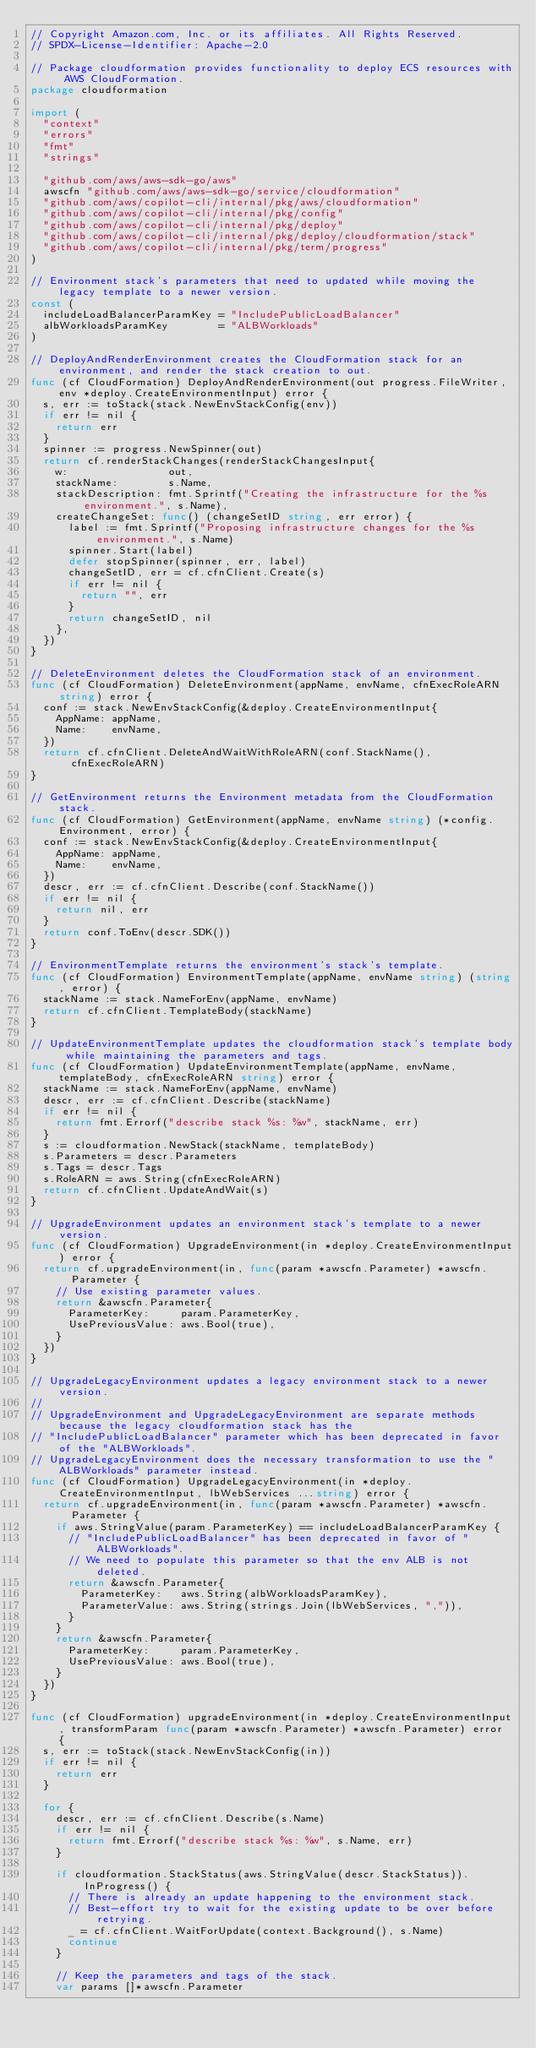<code> <loc_0><loc_0><loc_500><loc_500><_Go_>// Copyright Amazon.com, Inc. or its affiliates. All Rights Reserved.
// SPDX-License-Identifier: Apache-2.0

// Package cloudformation provides functionality to deploy ECS resources with AWS CloudFormation.
package cloudformation

import (
	"context"
	"errors"
	"fmt"
	"strings"

	"github.com/aws/aws-sdk-go/aws"
	awscfn "github.com/aws/aws-sdk-go/service/cloudformation"
	"github.com/aws/copilot-cli/internal/pkg/aws/cloudformation"
	"github.com/aws/copilot-cli/internal/pkg/config"
	"github.com/aws/copilot-cli/internal/pkg/deploy"
	"github.com/aws/copilot-cli/internal/pkg/deploy/cloudformation/stack"
	"github.com/aws/copilot-cli/internal/pkg/term/progress"
)

// Environment stack's parameters that need to updated while moving the legacy template to a newer version.
const (
	includeLoadBalancerParamKey = "IncludePublicLoadBalancer"
	albWorkloadsParamKey        = "ALBWorkloads"
)

// DeployAndRenderEnvironment creates the CloudFormation stack for an environment, and render the stack creation to out.
func (cf CloudFormation) DeployAndRenderEnvironment(out progress.FileWriter, env *deploy.CreateEnvironmentInput) error {
	s, err := toStack(stack.NewEnvStackConfig(env))
	if err != nil {
		return err
	}
	spinner := progress.NewSpinner(out)
	return cf.renderStackChanges(renderStackChangesInput{
		w:                out,
		stackName:        s.Name,
		stackDescription: fmt.Sprintf("Creating the infrastructure for the %s environment.", s.Name),
		createChangeSet: func() (changeSetID string, err error) {
			label := fmt.Sprintf("Proposing infrastructure changes for the %s environment.", s.Name)
			spinner.Start(label)
			defer stopSpinner(spinner, err, label)
			changeSetID, err = cf.cfnClient.Create(s)
			if err != nil {
				return "", err
			}
			return changeSetID, nil
		},
	})
}

// DeleteEnvironment deletes the CloudFormation stack of an environment.
func (cf CloudFormation) DeleteEnvironment(appName, envName, cfnExecRoleARN string) error {
	conf := stack.NewEnvStackConfig(&deploy.CreateEnvironmentInput{
		AppName: appName,
		Name:    envName,
	})
	return cf.cfnClient.DeleteAndWaitWithRoleARN(conf.StackName(), cfnExecRoleARN)
}

// GetEnvironment returns the Environment metadata from the CloudFormation stack.
func (cf CloudFormation) GetEnvironment(appName, envName string) (*config.Environment, error) {
	conf := stack.NewEnvStackConfig(&deploy.CreateEnvironmentInput{
		AppName: appName,
		Name:    envName,
	})
	descr, err := cf.cfnClient.Describe(conf.StackName())
	if err != nil {
		return nil, err
	}
	return conf.ToEnv(descr.SDK())
}

// EnvironmentTemplate returns the environment's stack's template.
func (cf CloudFormation) EnvironmentTemplate(appName, envName string) (string, error) {
	stackName := stack.NameForEnv(appName, envName)
	return cf.cfnClient.TemplateBody(stackName)
}

// UpdateEnvironmentTemplate updates the cloudformation stack's template body while maintaining the parameters and tags.
func (cf CloudFormation) UpdateEnvironmentTemplate(appName, envName, templateBody, cfnExecRoleARN string) error {
	stackName := stack.NameForEnv(appName, envName)
	descr, err := cf.cfnClient.Describe(stackName)
	if err != nil {
		return fmt.Errorf("describe stack %s: %w", stackName, err)
	}
	s := cloudformation.NewStack(stackName, templateBody)
	s.Parameters = descr.Parameters
	s.Tags = descr.Tags
	s.RoleARN = aws.String(cfnExecRoleARN)
	return cf.cfnClient.UpdateAndWait(s)
}

// UpgradeEnvironment updates an environment stack's template to a newer version.
func (cf CloudFormation) UpgradeEnvironment(in *deploy.CreateEnvironmentInput) error {
	return cf.upgradeEnvironment(in, func(param *awscfn.Parameter) *awscfn.Parameter {
		// Use existing parameter values.
		return &awscfn.Parameter{
			ParameterKey:     param.ParameterKey,
			UsePreviousValue: aws.Bool(true),
		}
	})
}

// UpgradeLegacyEnvironment updates a legacy environment stack to a newer version.
//
// UpgradeEnvironment and UpgradeLegacyEnvironment are separate methods because the legacy cloudformation stack has the
// "IncludePublicLoadBalancer" parameter which has been deprecated in favor of the "ALBWorkloads".
// UpgradeLegacyEnvironment does the necessary transformation to use the "ALBWorkloads" parameter instead.
func (cf CloudFormation) UpgradeLegacyEnvironment(in *deploy.CreateEnvironmentInput, lbWebServices ...string) error {
	return cf.upgradeEnvironment(in, func(param *awscfn.Parameter) *awscfn.Parameter {
		if aws.StringValue(param.ParameterKey) == includeLoadBalancerParamKey {
			// "IncludePublicLoadBalancer" has been deprecated in favor of "ALBWorkloads".
			// We need to populate this parameter so that the env ALB is not deleted.
			return &awscfn.Parameter{
				ParameterKey:   aws.String(albWorkloadsParamKey),
				ParameterValue: aws.String(strings.Join(lbWebServices, ",")),
			}
		}
		return &awscfn.Parameter{
			ParameterKey:     param.ParameterKey,
			UsePreviousValue: aws.Bool(true),
		}
	})
}

func (cf CloudFormation) upgradeEnvironment(in *deploy.CreateEnvironmentInput, transformParam func(param *awscfn.Parameter) *awscfn.Parameter) error {
	s, err := toStack(stack.NewEnvStackConfig(in))
	if err != nil {
		return err
	}

	for {
		descr, err := cf.cfnClient.Describe(s.Name)
		if err != nil {
			return fmt.Errorf("describe stack %s: %w", s.Name, err)
		}

		if cloudformation.StackStatus(aws.StringValue(descr.StackStatus)).InProgress() {
			// There is already an update happening to the environment stack.
			// Best-effort try to wait for the existing update to be over before retrying.
			_ = cf.cfnClient.WaitForUpdate(context.Background(), s.Name)
			continue
		}

		// Keep the parameters and tags of the stack.
		var params []*awscfn.Parameter</code> 